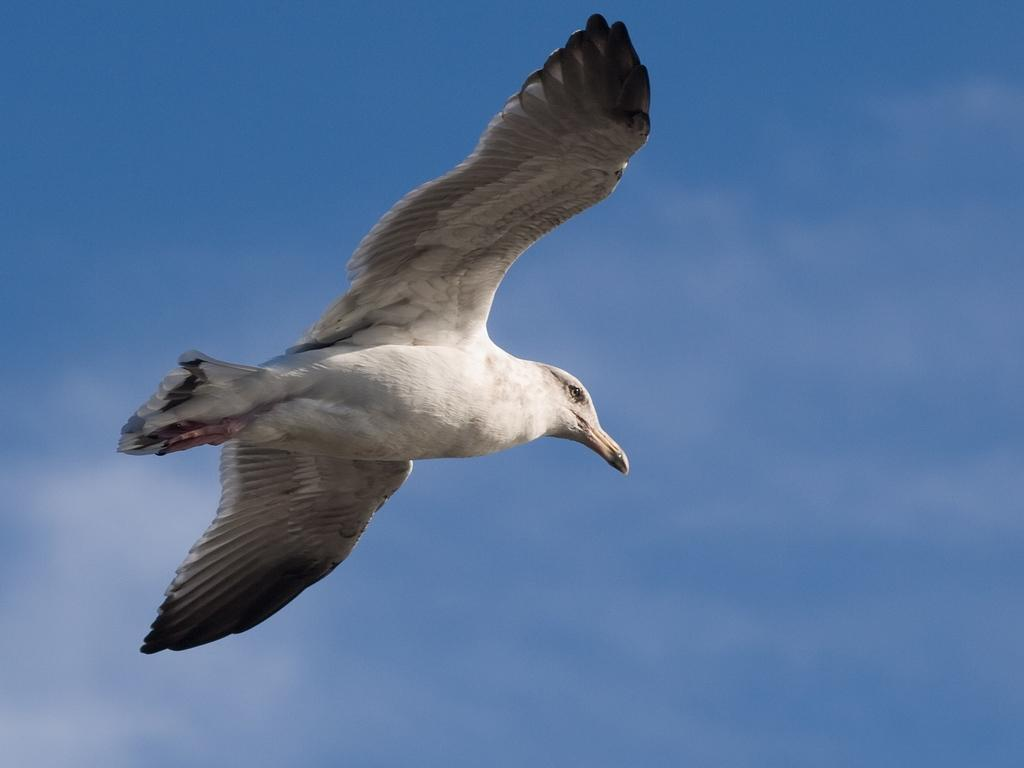What is present in the image? There is a bird in the image. What is the bird doing in the image? The bird is flying in the sky. What type of stamp can be seen on the bird's wing in the image? There is no stamp present on the bird's wing in the image. What kind of cakes are being served at the bird's party in the image? There is no party or cakes present in the image; it only features a bird flying in the sky. 